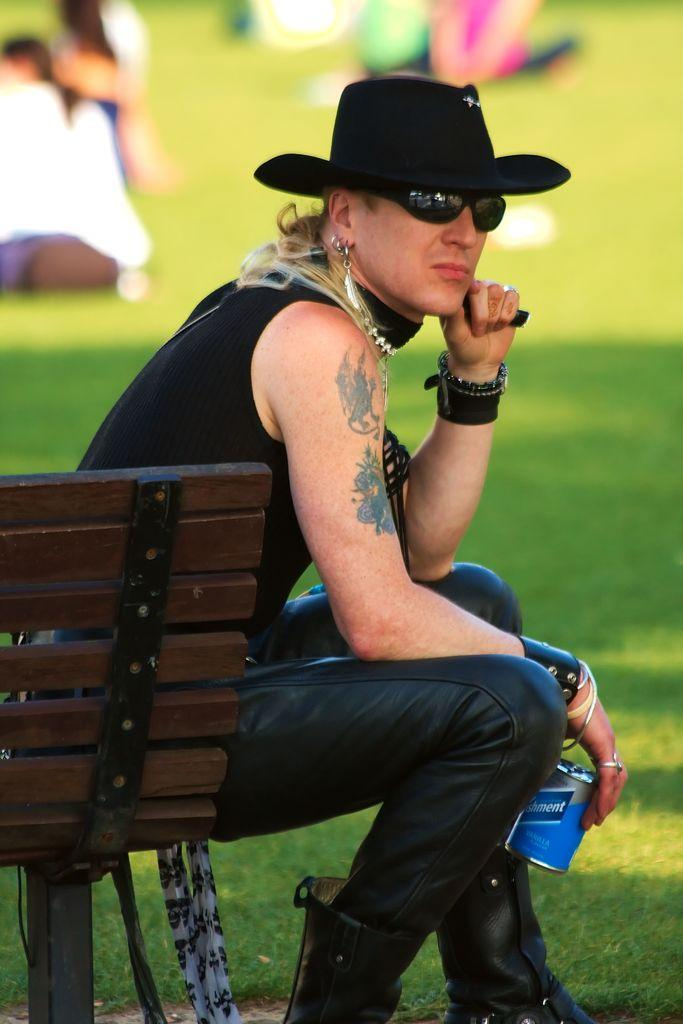What is the man in the image doing? The man is sitting on a bench in the image. What is the man holding in his hands? The man is holding a beverage tin in his hands. What can be seen in the background of the image? In the background of the image, there are people sitting on the ground. How many ducks are visible in the image? There are no ducks present in the image. What type of base is supporting the bench in the image? The image does not show the base of the bench, so it cannot be determined from the image. 